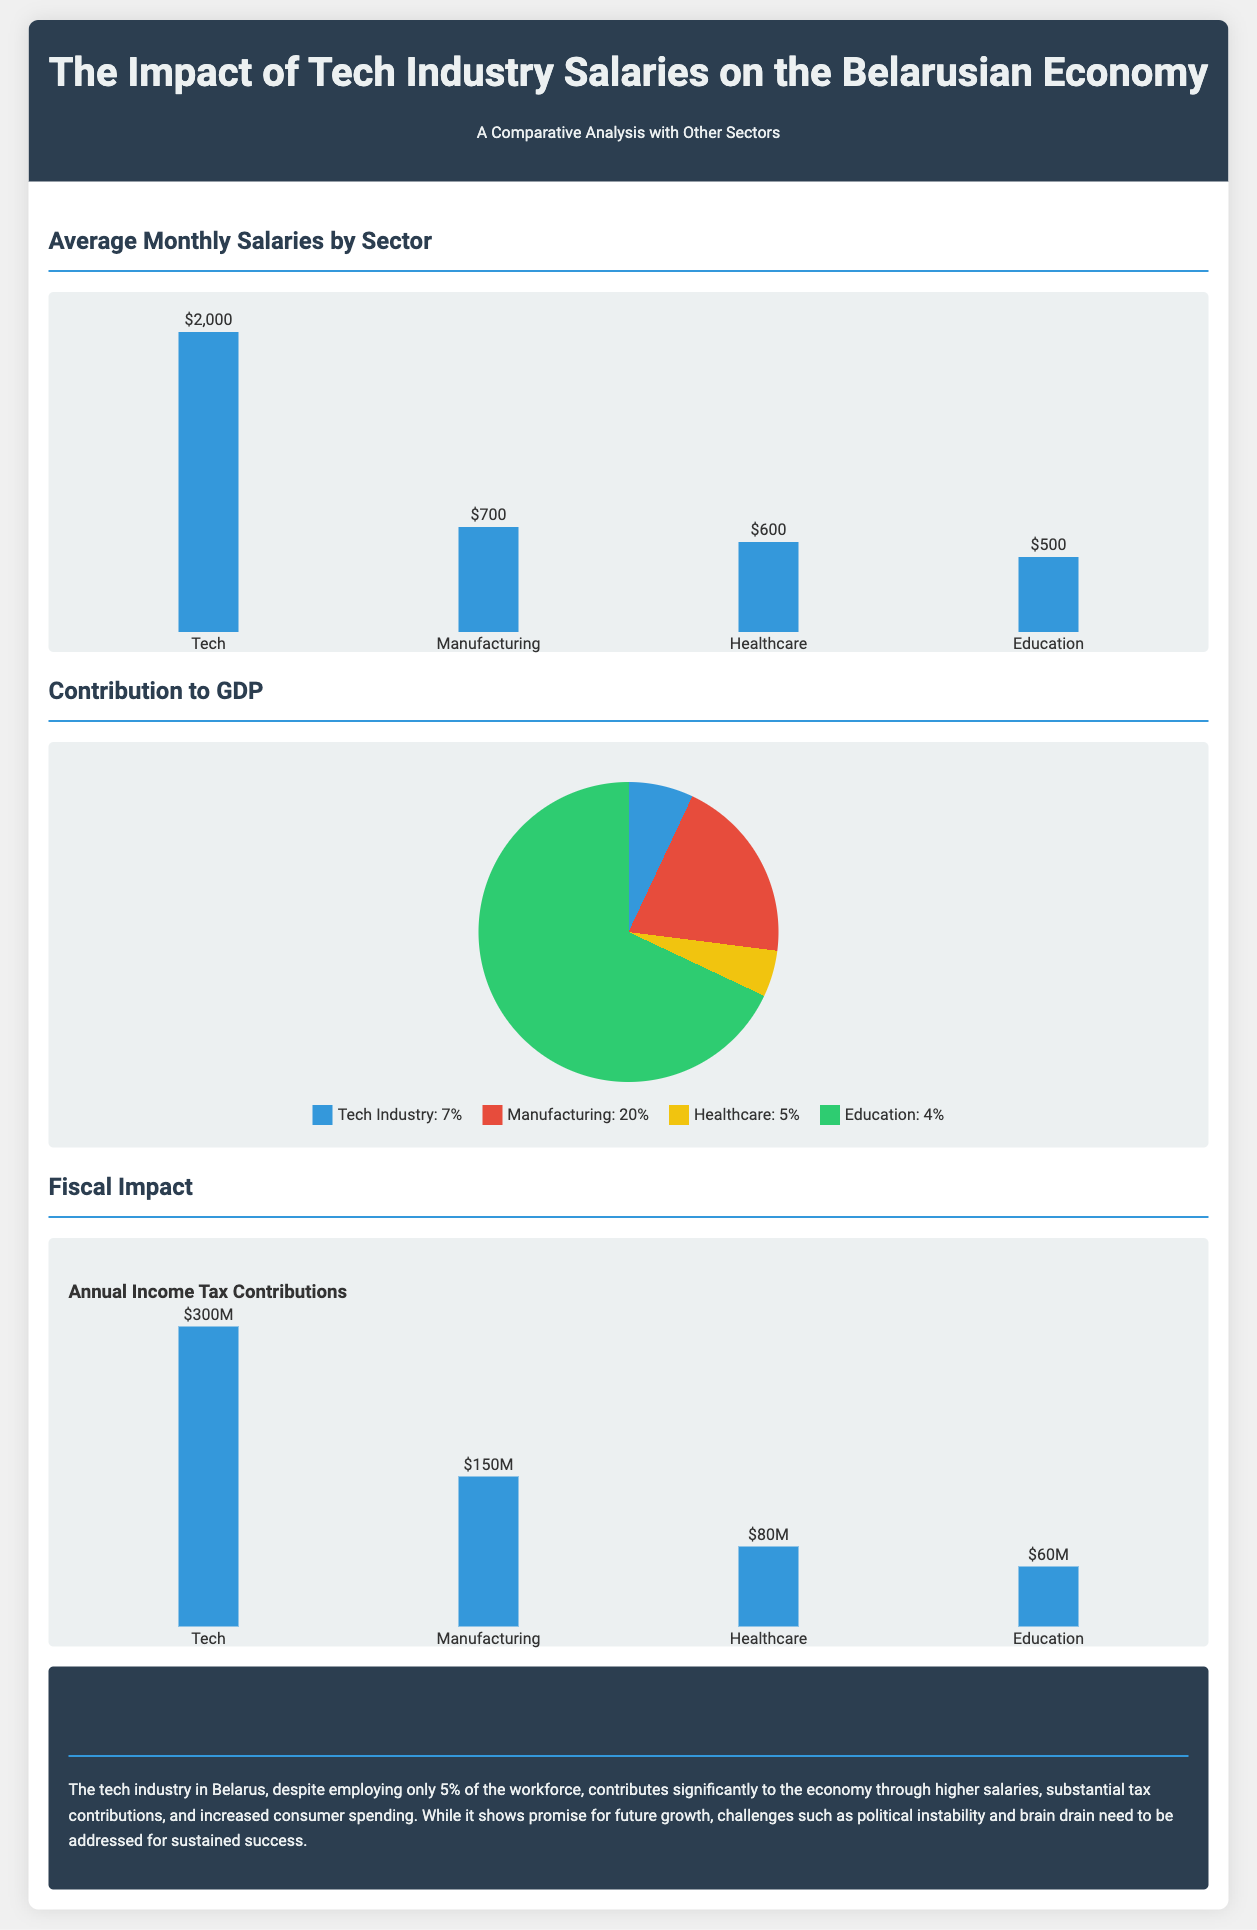What is the average monthly salary in the tech sector? The average monthly salary shown in the document for the tech sector is depicted in the bar chart as $2,000.
Answer: $2,000 What percentage of GDP does the tech industry contribute? The pie chart illustrates that the tech industry contributes 7% to the GDP of Belarus.
Answer: 7% What is the annual income tax contribution from the tech industry? The bar chart indicates that the annual income tax contributions from the tech industry amount to $300 million.
Answer: $300M Which sector has the highest average monthly salary? According to the bar chart, the tech sector has the highest average monthly salary at $2,000 compared to other sectors.
Answer: Tech What is the fiscal impact comparison of manufacturing vs. tech? The comparison illustrates that manufacturing contributes $150 million in annual income tax, while tech contributes $300 million, indicating tech's higher fiscal impact.
Answer: Tech's fiscal impact is higher What is the average monthly salary in education? The document shows that the average monthly salary in education is represented in the bar chart as $500.
Answer: $500 What percentage of healthcare contributes to GDP? The document indicates that healthcare contributes 5% to the GDP as represented in the pie chart.
Answer: 5% What challenge is mentioned for the tech industry's success? The conclusion states that political instability is one of the challenges that need to be addressed for sustained success in the tech industry.
Answer: Political instability What is the total percentage contribution of manufacturing to GDP? The document states that manufacturing contributes 20% to the GDP as shown in the pie chart.
Answer: 20% 